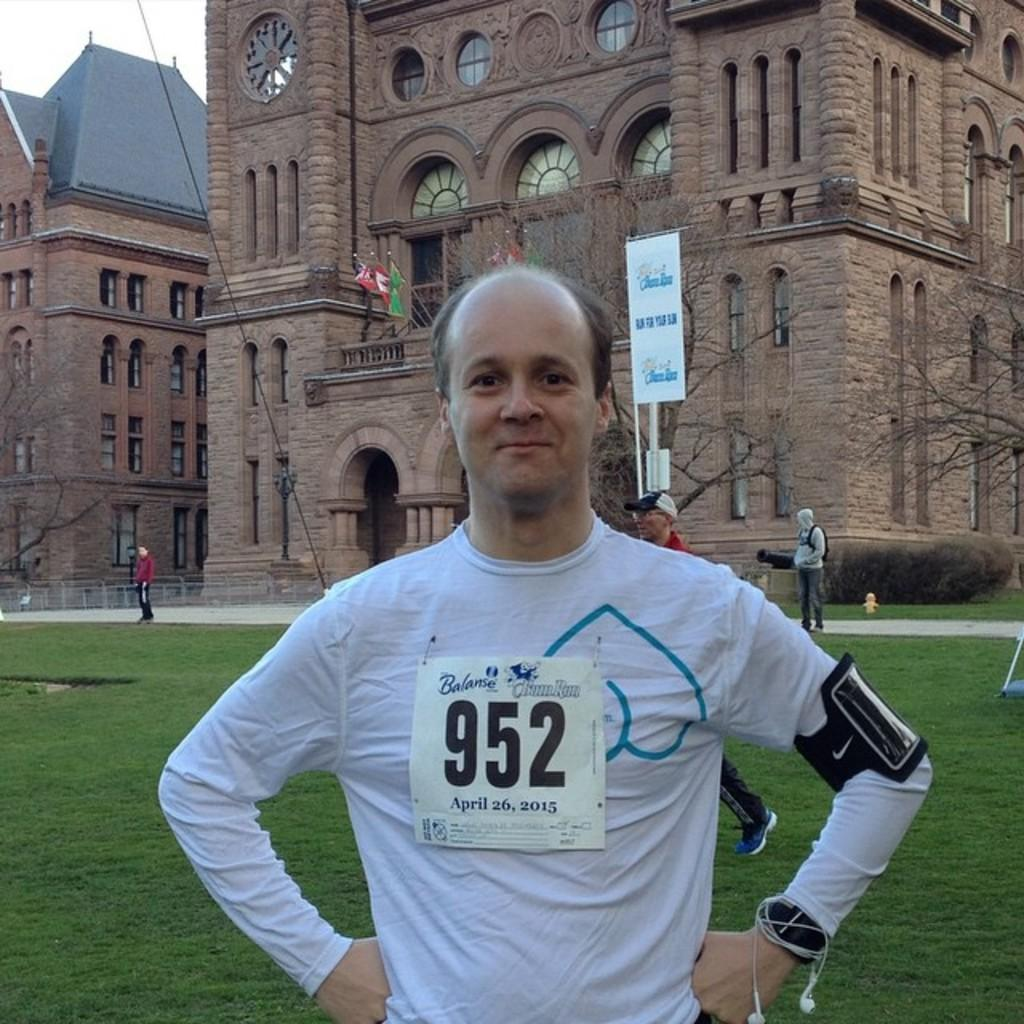What is the main subject of the image? There is a person standing in the image. What is the person wearing? The person is wearing a white shirt. Can you describe the surroundings of the person? There are other people standing in the background of the image, and there are brown-colored buildings in the background as well. What can be seen in the sky in the image? The sky is visible in the background of the image and appears to be white in color. What type of dress is the stranger wearing in the image? There is no stranger present in the image, and therefore no dress can be observed. What is the porter carrying in the image? There is no porter present in the image, so it is not possible to determine what they might be carrying. 